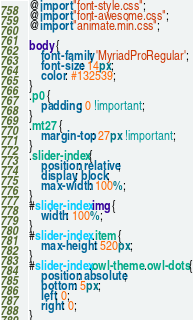<code> <loc_0><loc_0><loc_500><loc_500><_CSS_>
@import "font-style.css";
@import "font-awesome.css";
@import "animate.min.css";

body {
    font-family: 'MyriadProRegular';
    font-size: 14px;
    color: #132539;
}
.p0 {
    padding: 0 !important;
}
.mt27 {
    margin-top: 27px !important;
}
.slider-index {
    position: relative;
    display: block;
    max-width: 100%;
}
#slider-index img {
    width: 100%;
}
#slider-index .item {
    max-height: 520px;
}
#slider-index.owl-theme .owl-dots {
    position: absolute;
    bottom: 5px;
    left: 0;
    right: 0;
}</code> 